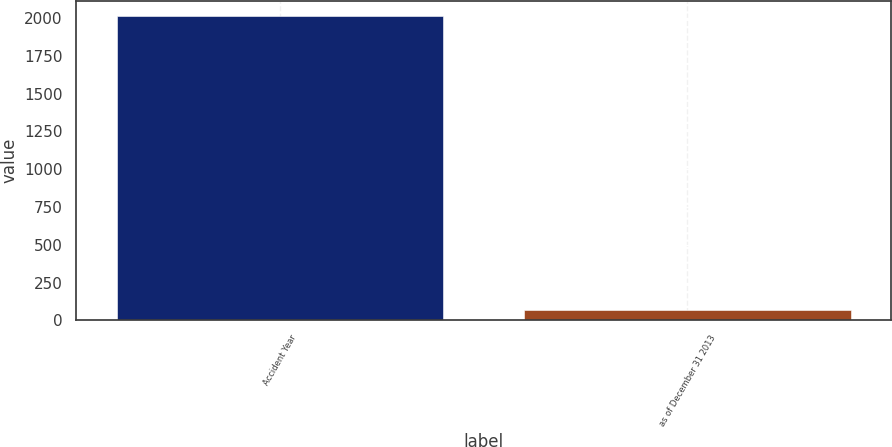<chart> <loc_0><loc_0><loc_500><loc_500><bar_chart><fcel>Accident Year<fcel>as of December 31 2013<nl><fcel>2011<fcel>67<nl></chart> 